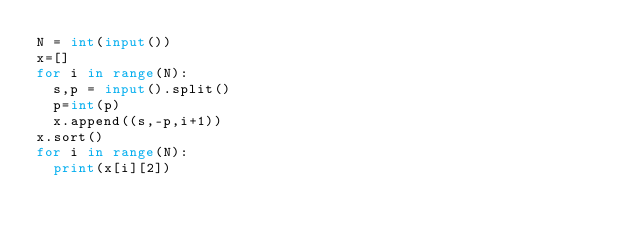Convert code to text. <code><loc_0><loc_0><loc_500><loc_500><_Python_>N = int(input())
x=[]
for i in range(N):
  s,p = input().split()
  p=int(p)
  x.append((s,-p,i+1))
x.sort()  
for i in range(N):
  print(x[i][2])</code> 